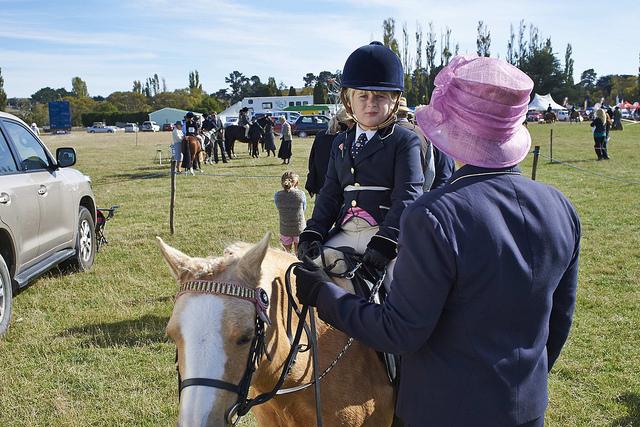What is the girl riding?
Answer briefly. Horse. What color hat is the man wearing?
Short answer required. Pink. Are the horses eyes open or closed?
Write a very short answer. Open. What kind of hat?
Write a very short answer. Riding. Is this a fair?
Short answer required. Yes. 